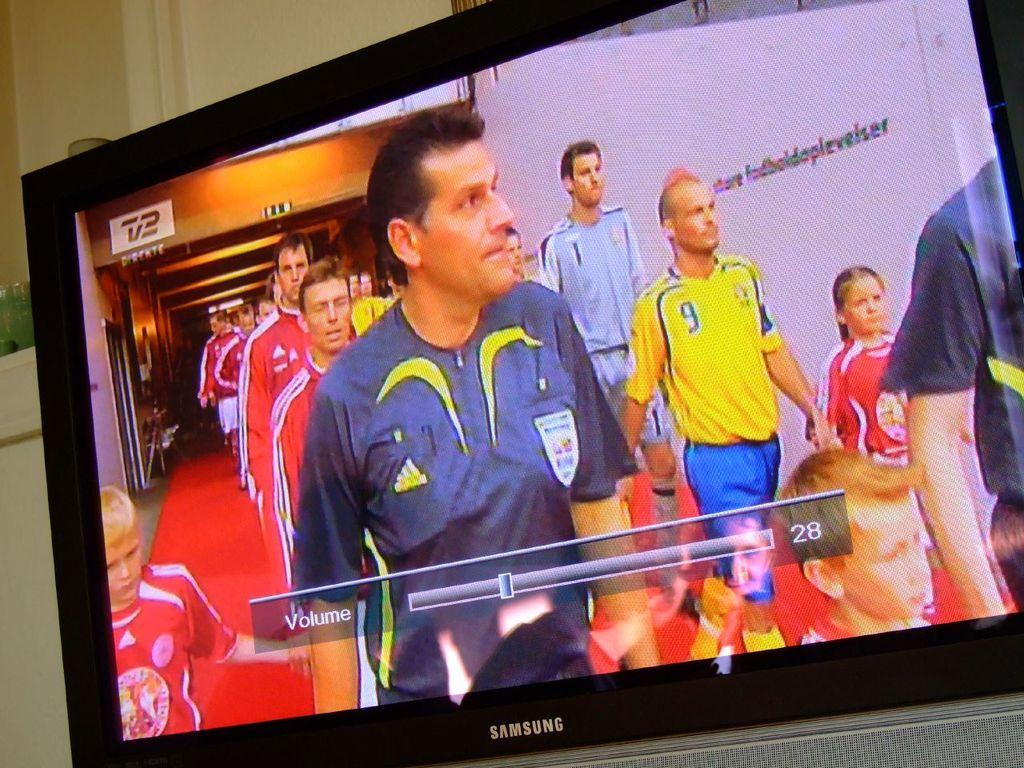<image>
Provide a brief description of the given image. A tv is displayed with the volume at 28 